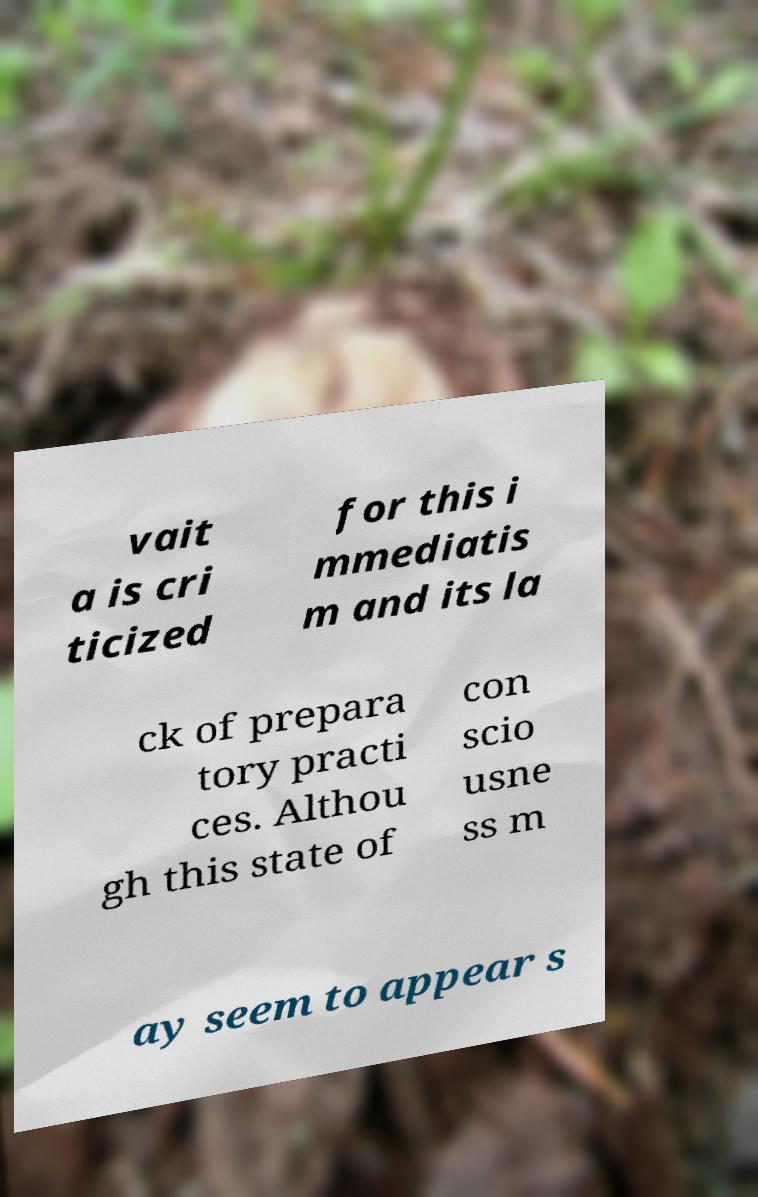What messages or text are displayed in this image? I need them in a readable, typed format. vait a is cri ticized for this i mmediatis m and its la ck of prepara tory practi ces. Althou gh this state of con scio usne ss m ay seem to appear s 